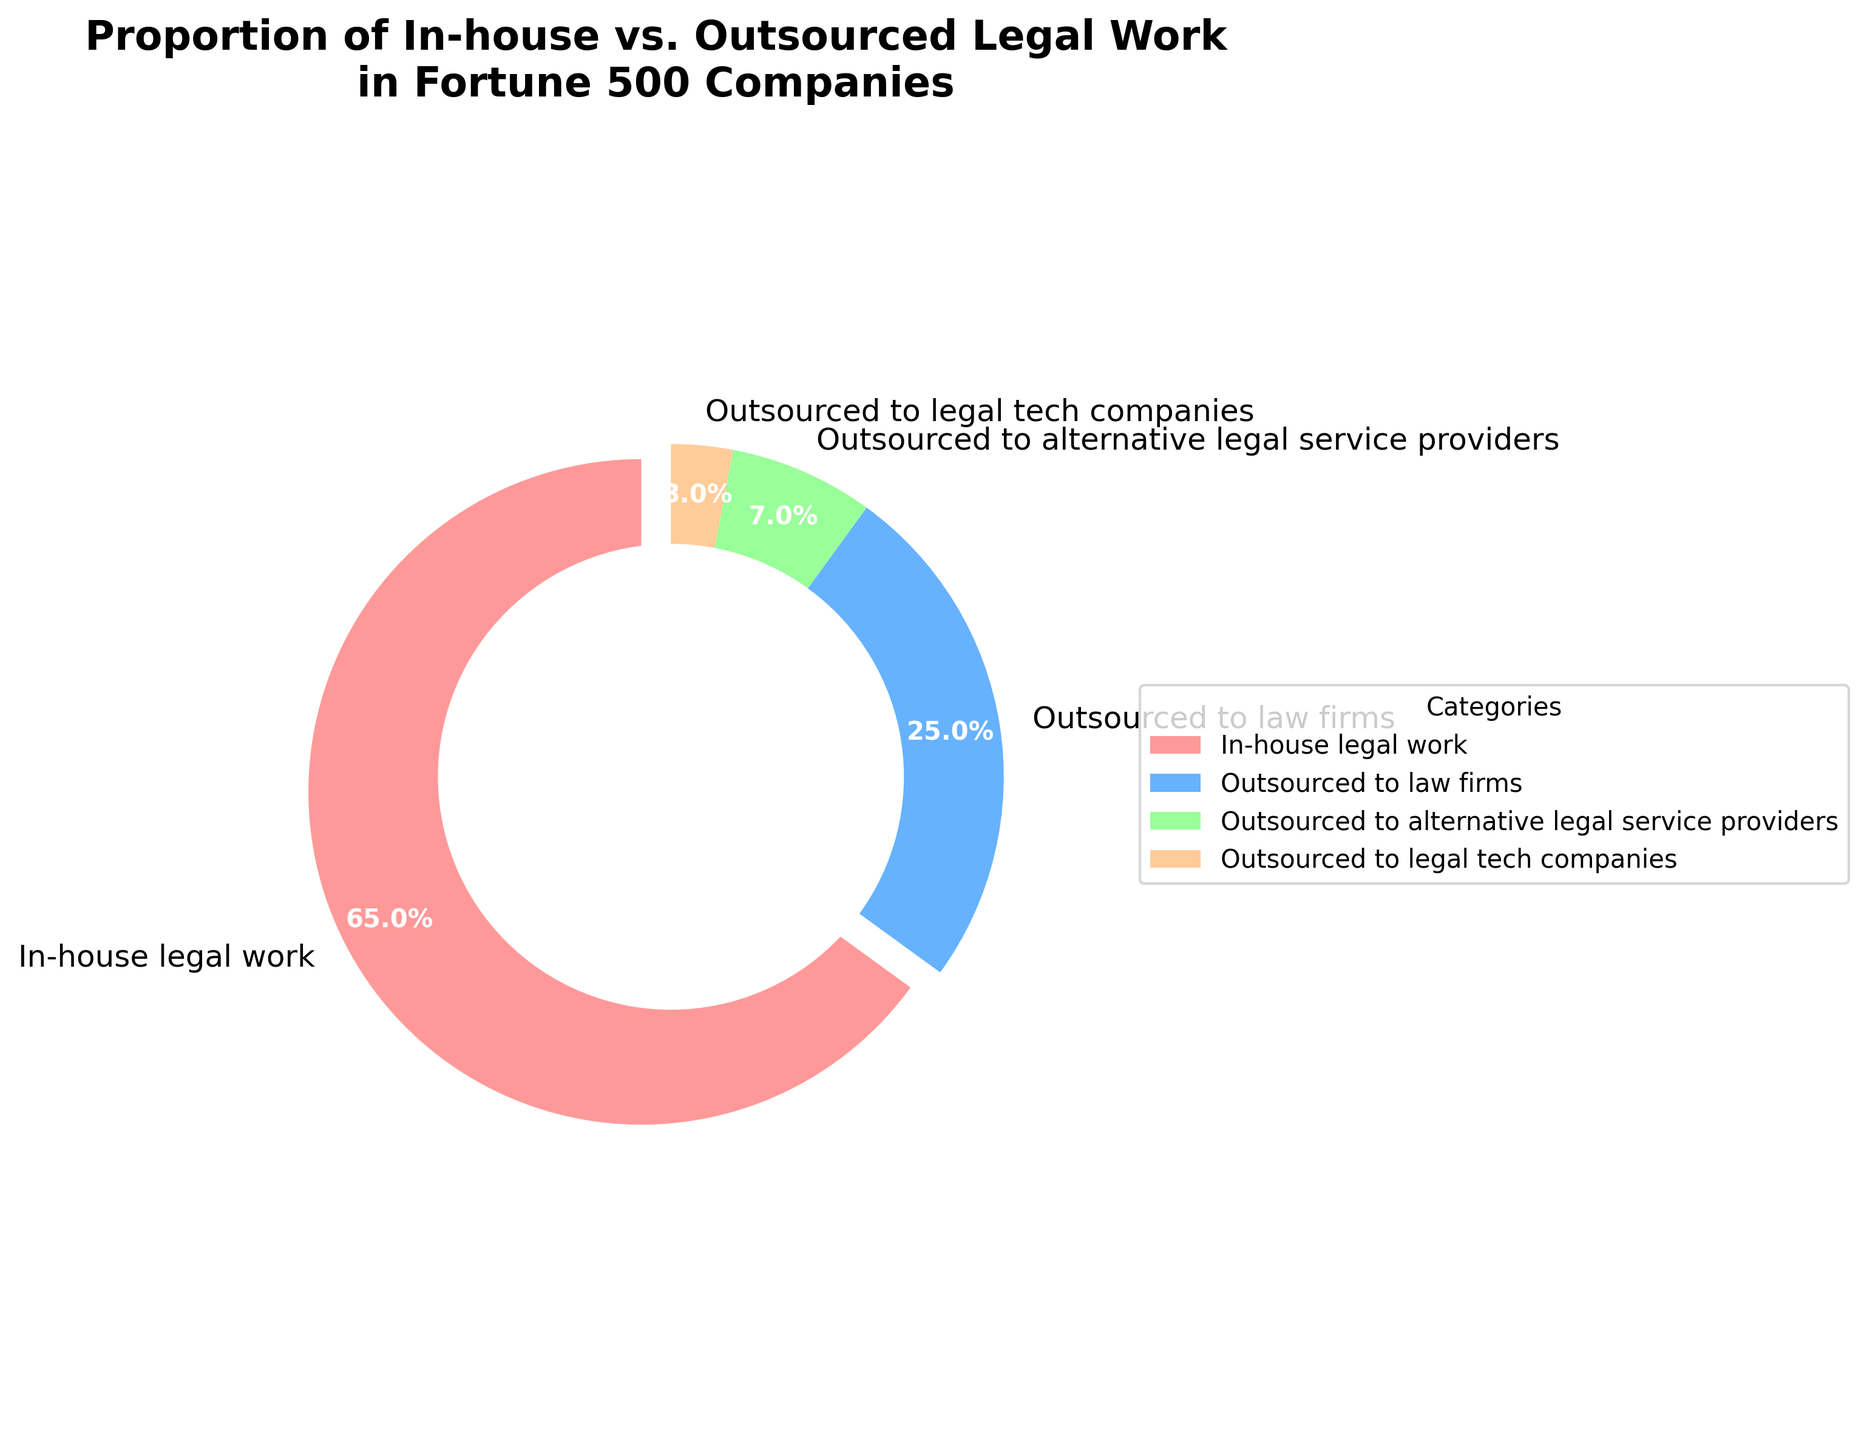What percentage of legal work is outsourced to external providers? Add the percentages for outsourced to law firms, alternative legal service providers, and legal tech companies: 25% + 7% + 3% = 35%
Answer: 35% Which category accounts for the largest portion of legal work? Look at the category with the largest slice of the pie chart; it is "In-house legal work" with 65%.
Answer: In-house legal work How much more legal work is done in-house compared to being outsourced to law firms? Subtract the percentage of outsourced to law firms from the in-house legal work: 65% - 25% = 40%
Answer: 40% What is the combined percentage of legal work that is outsourced to alternative legal service providers and legal tech companies? Add the percentages for alternative legal service providers and legal tech companies: 7% + 3% = 10%
Answer: 10% Which category has the smallest portion of legal work? Look at the category with the smallest slice of the pie chart; it is "Outsourced to legal tech companies" with 3%.
Answer: OutSourced to legal tech companies What proportion of the work is done neither in-house nor outsourced to law firms? Add the percentages of outsourced to alternative legal service providers and legal tech companies: 7% + 3% = 10%
Answer: 10% How does the percentage of in-house legal work compare to the combined total of all outsourced work? Compare the in-house work percentage (65%) to the total outsourced work percentage (35%): 65% > 35%
Answer: 65% > 35% How much more work is outsourced to law firms compared to alternative legal service providers? Subtract the percentage of alternative legal service providers from the percentage of outsourced to law firms: 25% - 7% = 18%
Answer: 18% What portion of work is outsourced to either law firms or legal tech companies? Add the percentages for law firms and legal tech companies: 25% + 3% = 28%
Answer: 28% Which slice of the pie chart is largest, and what color is it? Identify the largest slice, which is "In-house legal work," and note its color, which is red.
Answer: In-house legal work, red 